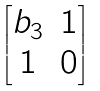<formula> <loc_0><loc_0><loc_500><loc_500>\begin{bmatrix} b _ { 3 } & 1 \\ 1 & 0 \end{bmatrix}</formula> 